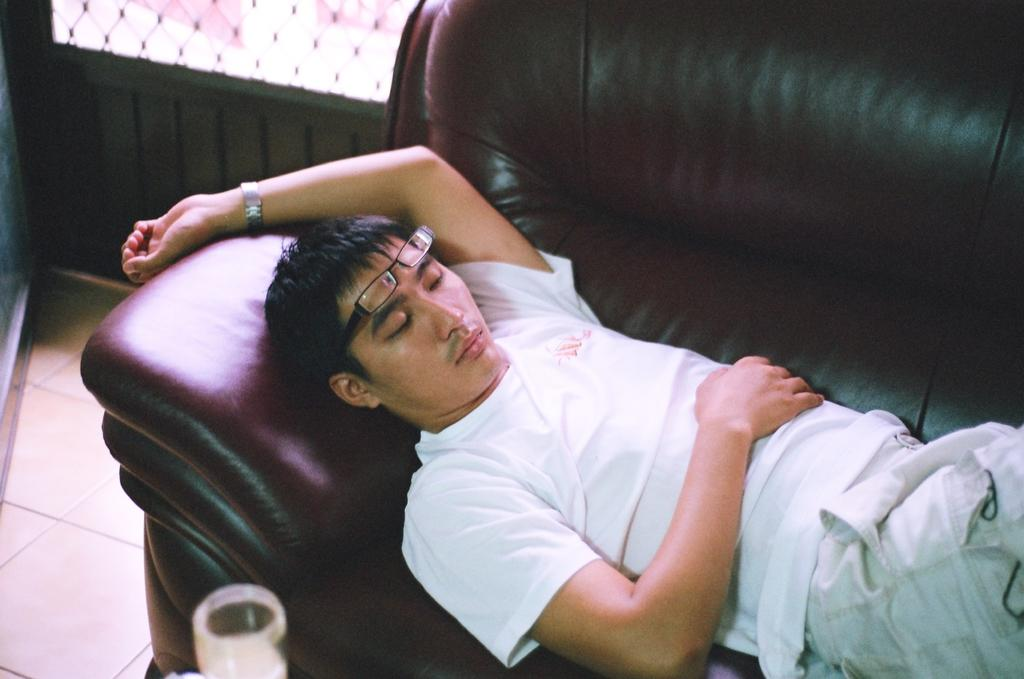Who is present in the image? There is a man in the image. What is the man doing in the image? The man is sleeping on a sofa. What accessories is the man wearing in the image? The man is wearing spectacles and a watch. What object can be seen at the bottom of the image? There is a glass at the bottom of the image. What is visible in the background of the image? There is a window in the background of the image. What type of juice is the man drinking in the image? There is no juice present in the image; the man is sleeping on a sofa and there is a glass at the bottom of the image, but no liquid is visible. 